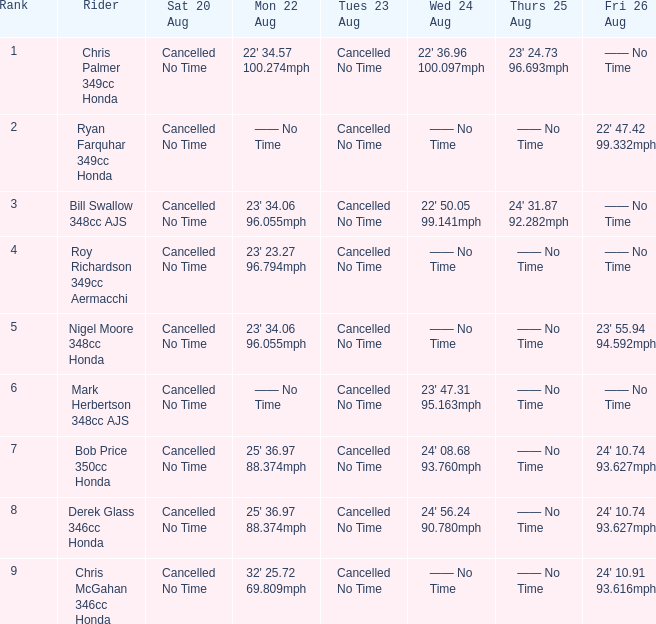Parse the table in full. {'header': ['Rank', 'Rider', 'Sat 20 Aug', 'Mon 22 Aug', 'Tues 23 Aug', 'Wed 24 Aug', 'Thurs 25 Aug', 'Fri 26 Aug'], 'rows': [['1', 'Chris Palmer 349cc Honda', 'Cancelled No Time', "22' 34.57 100.274mph", 'Cancelled No Time', "22' 36.96 100.097mph", "23' 24.73 96.693mph", '—— No Time'], ['2', 'Ryan Farquhar 349cc Honda', 'Cancelled No Time', '—— No Time', 'Cancelled No Time', '—— No Time', '—— No Time', "22' 47.42 99.332mph"], ['3', 'Bill Swallow 348cc AJS', 'Cancelled No Time', "23' 34.06 96.055mph", 'Cancelled No Time', "22' 50.05 99.141mph", "24' 31.87 92.282mph", '—— No Time'], ['4', 'Roy Richardson 349cc Aermacchi', 'Cancelled No Time', "23' 23.27 96.794mph", 'Cancelled No Time', '—— No Time', '—— No Time', '—— No Time'], ['5', 'Nigel Moore 348cc Honda', 'Cancelled No Time', "23' 34.06 96.055mph", 'Cancelled No Time', '—— No Time', '—— No Time', "23' 55.94 94.592mph"], ['6', 'Mark Herbertson 348cc AJS', 'Cancelled No Time', '—— No Time', 'Cancelled No Time', "23' 47.31 95.163mph", '—— No Time', '—— No Time'], ['7', 'Bob Price 350cc Honda', 'Cancelled No Time', "25' 36.97 88.374mph", 'Cancelled No Time', "24' 08.68 93.760mph", '—— No Time', "24' 10.74 93.627mph"], ['8', 'Derek Glass 346cc Honda', 'Cancelled No Time', "25' 36.97 88.374mph", 'Cancelled No Time', "24' 56.24 90.780mph", '—— No Time', "24' 10.74 93.627mph"], ['9', 'Chris McGahan 346cc Honda', 'Cancelled No Time', "32' 25.72 69.809mph", 'Cancelled No Time', '—— No Time', '—— No Time', "24' 10.91 93.616mph"]]} What is each record on monday august 22 when the data for wednesday august 24 is 22' 5 23' 34.06 96.055mph. 